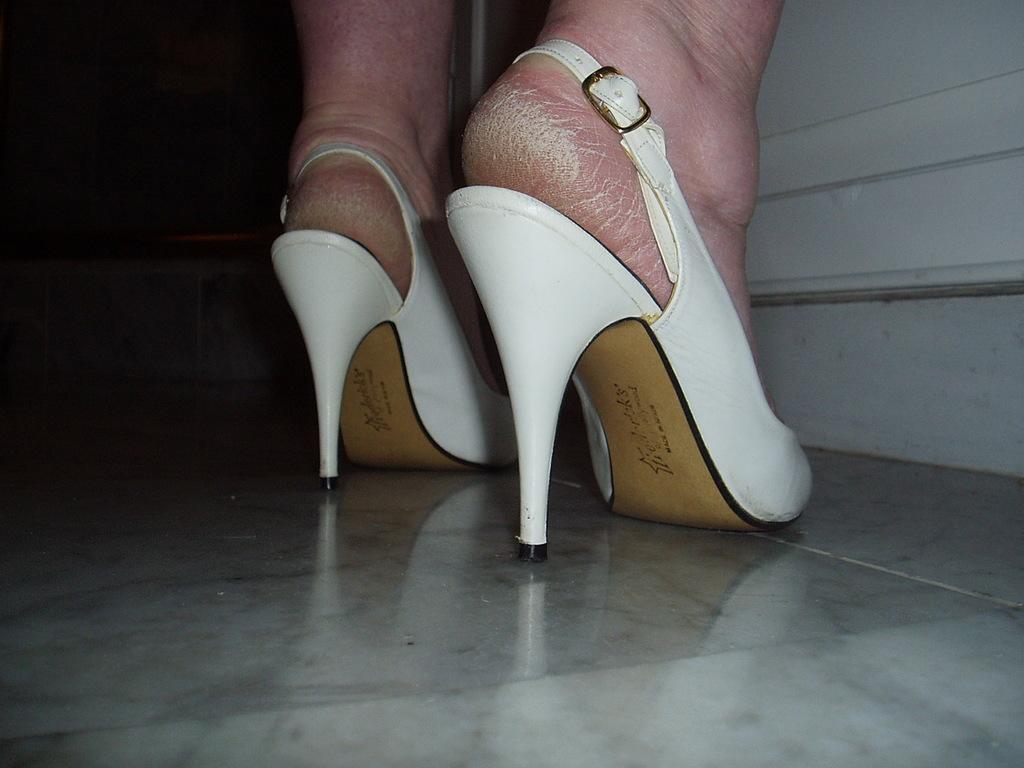Could you give a brief overview of what you see in this image? We can see a person's foot with white color footwear. Under the footwear something is written. And it is on a floor. In the back we can see a white wall. 